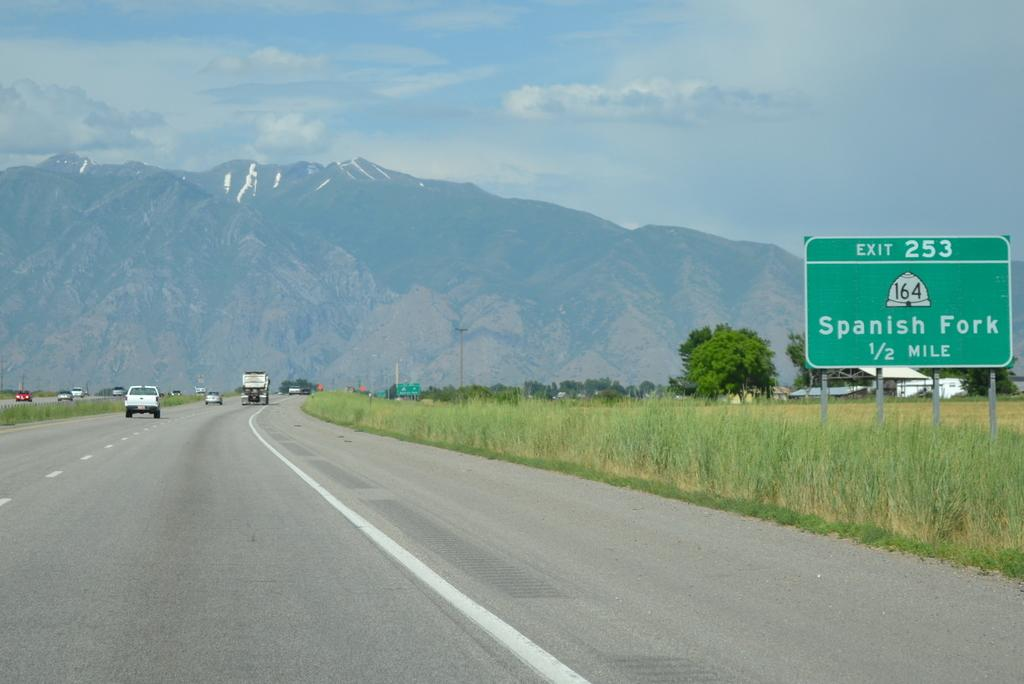<image>
Give a short and clear explanation of the subsequent image. A freeway with cars driving down it and there is a sign to the side that reads Exit 253 Spanish Fork 1/2 mile 